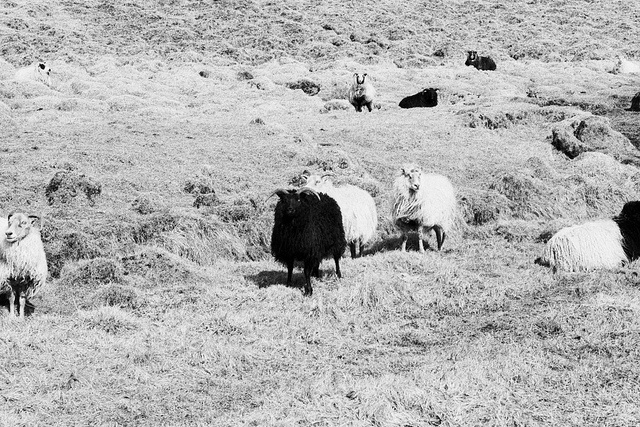Describe the objects in this image and their specific colors. I can see sheep in lightgray, black, gray, and darkgray tones, sheep in lightgray, black, darkgray, and gray tones, sheep in lightgray, darkgray, black, and gray tones, sheep in lightgray, darkgray, black, and gray tones, and sheep in lightgray, darkgray, black, and gray tones in this image. 